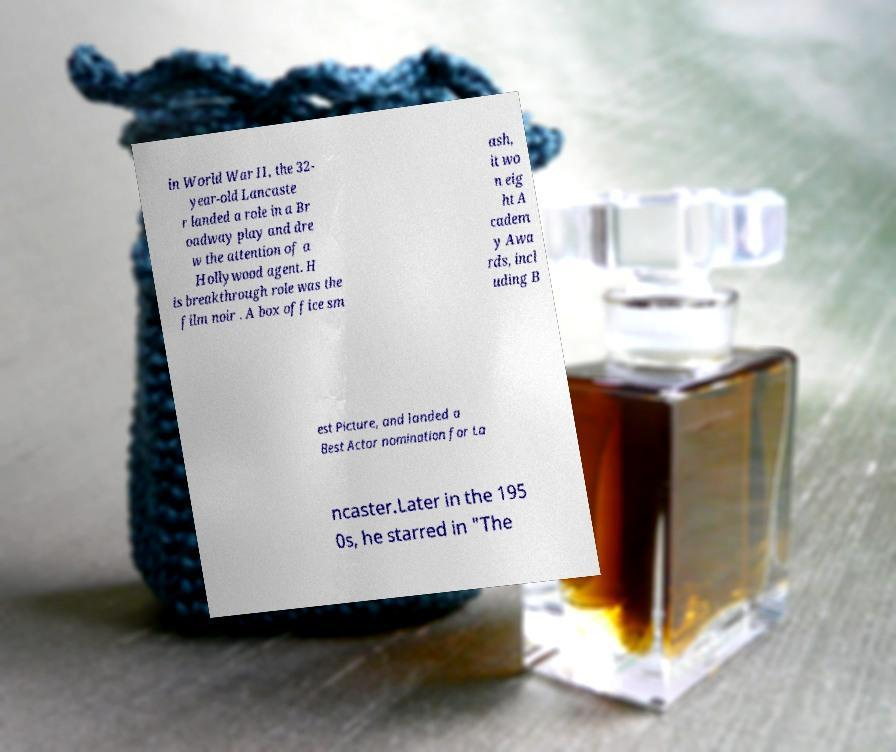Can you accurately transcribe the text from the provided image for me? in World War II, the 32- year-old Lancaste r landed a role in a Br oadway play and dre w the attention of a Hollywood agent. H is breakthrough role was the film noir . A box office sm ash, it wo n eig ht A cadem y Awa rds, incl uding B est Picture, and landed a Best Actor nomination for La ncaster.Later in the 195 0s, he starred in "The 